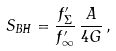<formula> <loc_0><loc_0><loc_500><loc_500>S _ { B H } = \frac { f ^ { \prime } _ { \Sigma } } { f ^ { \prime } _ { \infty } } \, \frac { A } { 4 G } \, ,</formula> 